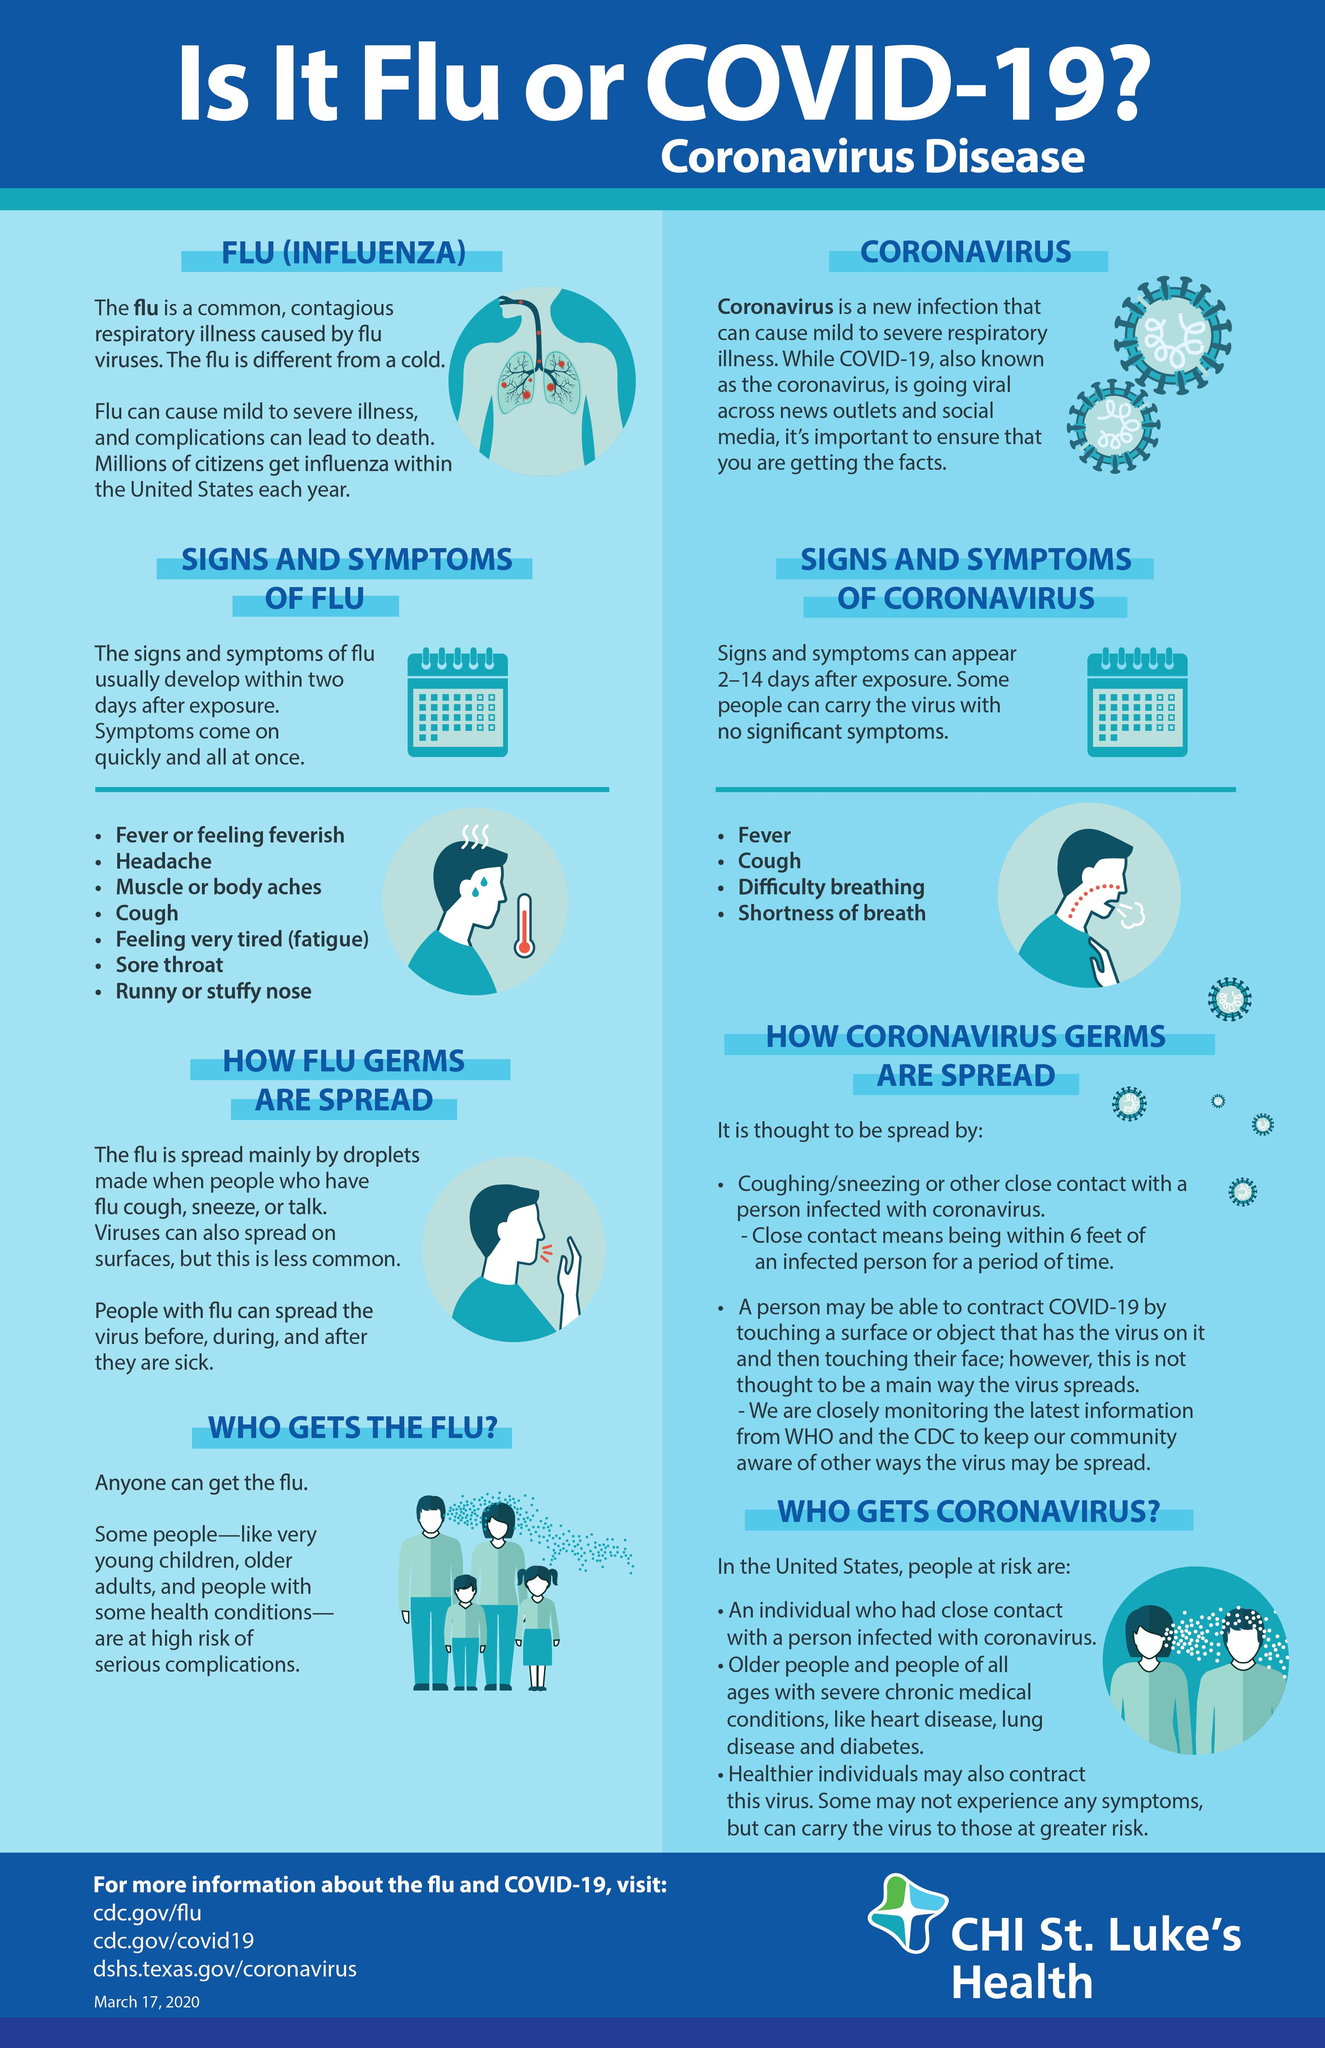Identify some key points in this picture. Both the flu and COVID-19 are characterized by symptoms such as fever and cough. 